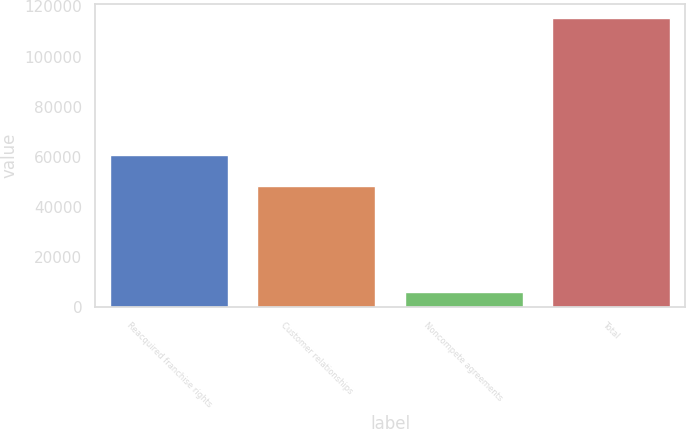Convert chart to OTSL. <chart><loc_0><loc_0><loc_500><loc_500><bar_chart><fcel>Reacquired franchise rights<fcel>Customer relationships<fcel>Noncompete agreements<fcel>Total<nl><fcel>60906<fcel>48298<fcel>6000<fcel>115204<nl></chart> 